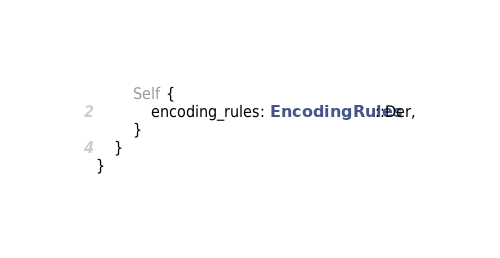<code> <loc_0><loc_0><loc_500><loc_500><_Rust_>        Self {
            encoding_rules: EncodingRules::Der,
        }
    }
}
</code> 